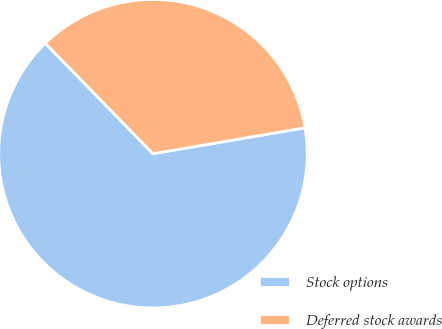<chart> <loc_0><loc_0><loc_500><loc_500><pie_chart><fcel>Stock options<fcel>Deferred stock awards<nl><fcel>65.38%<fcel>34.62%<nl></chart> 